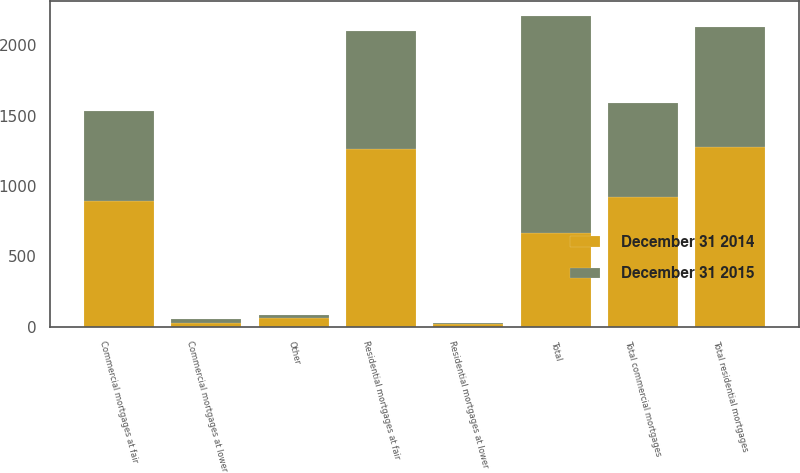Convert chart to OTSL. <chart><loc_0><loc_0><loc_500><loc_500><stacked_bar_chart><ecel><fcel>Commercial mortgages at fair<fcel>Commercial mortgages at lower<fcel>Total commercial mortgages<fcel>Residential mortgages at fair<fcel>Residential mortgages at lower<fcel>Total residential mortgages<fcel>Other<fcel>Total<nl><fcel>December 31 2015<fcel>641<fcel>27<fcel>668<fcel>843<fcel>7<fcel>850<fcel>22<fcel>1540<nl><fcel>December 31 2014<fcel>893<fcel>29<fcel>922<fcel>1261<fcel>18<fcel>1279<fcel>61<fcel>668<nl></chart> 